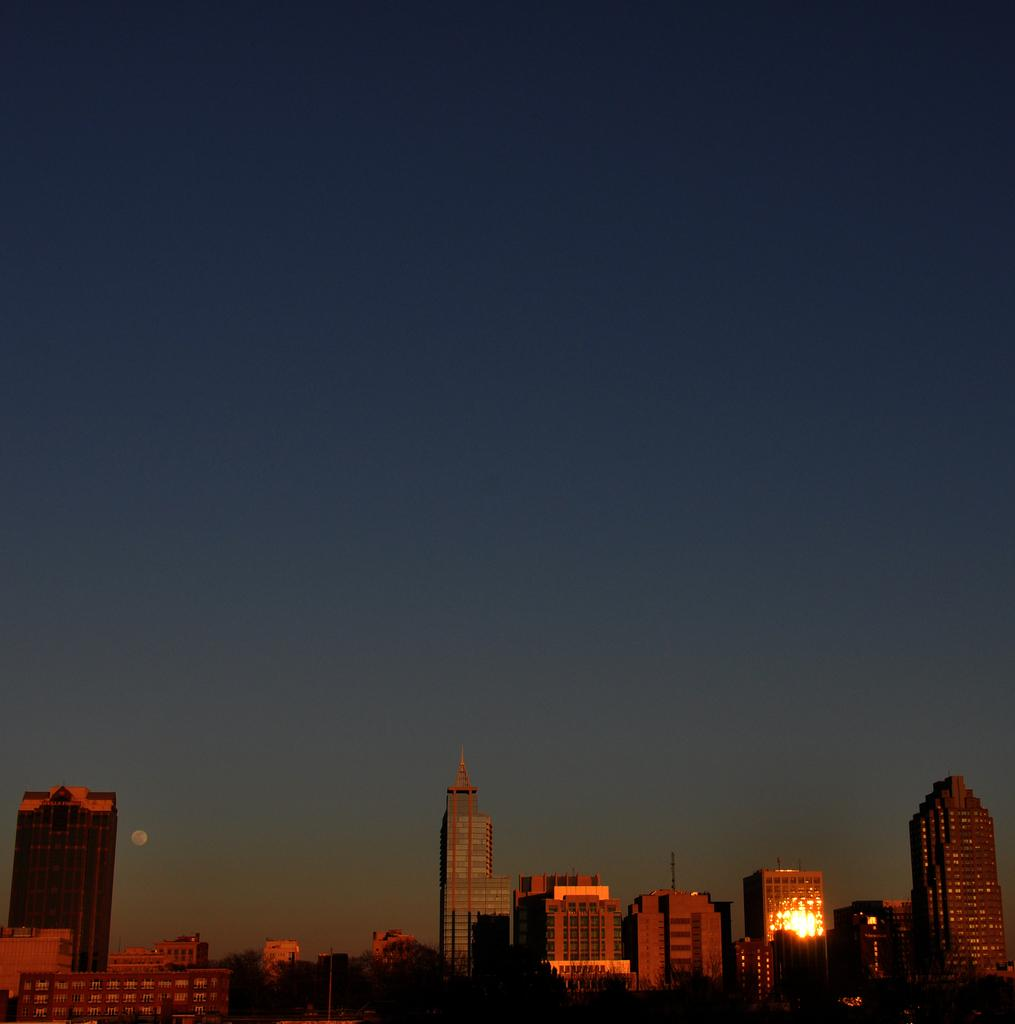What type of natural elements can be seen in the image? There are trees in the image. What type of man-made structures are present in the image? There are buildings in the image. What part of the natural environment is visible in the image? The sky is visible in the image. What emotion can be seen on the side of the tree in the image? There is no emotion present on the side of the tree in the image, as trees do not have emotions. 